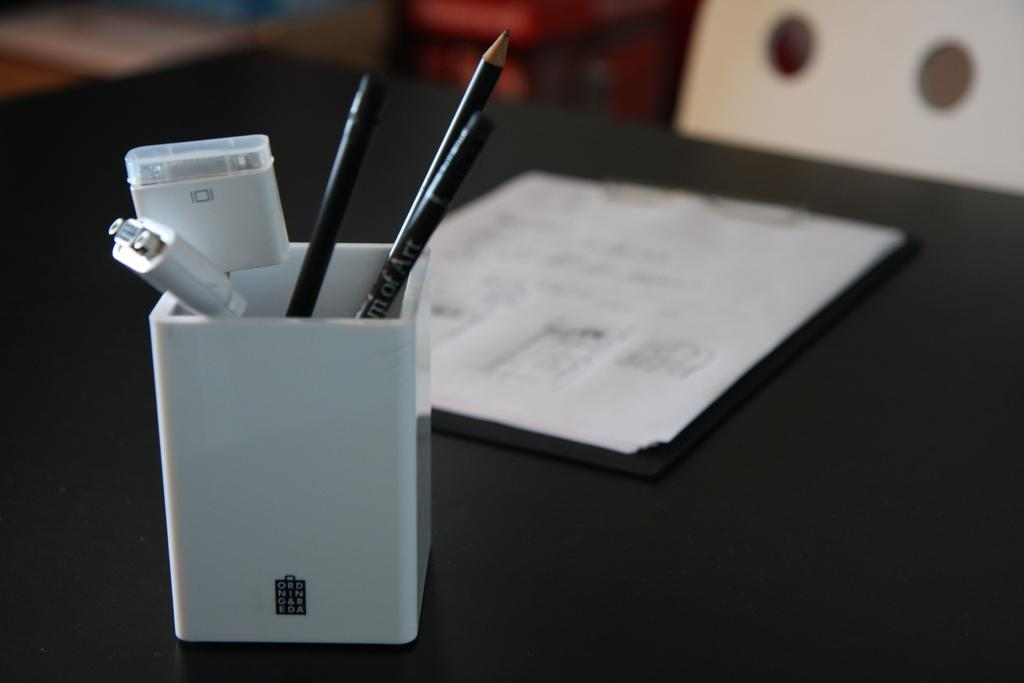What object is used for holding pens in the image? There is a pen holder in the image. Where is the pen holder located? The pen holder is placed on a table. What is the color of the paper pad in the image? The paper pad in the image is white. What type of furniture can be seen in the background of the image? A white chair is visible in the background of the image. What is the income of the person who owns the pen holder in the image? There is no information about the income of the person who owns the pen holder in the image. 